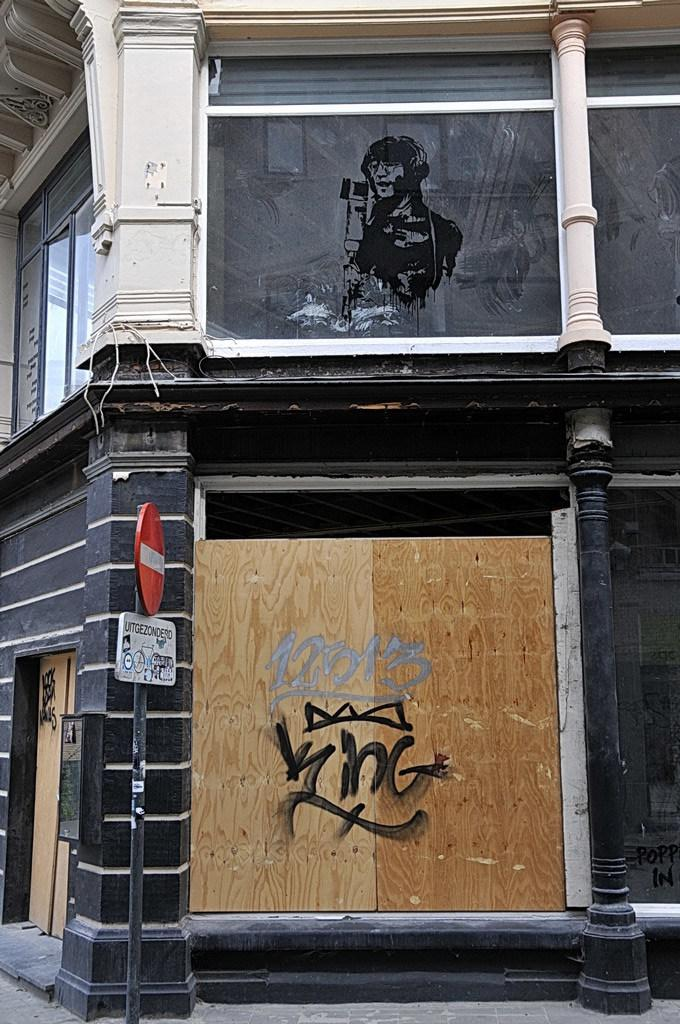What is the main subject of the image? There is a painting in the image. Are there any other paintings visible in the image? Yes, there are paintings on the wall. What else can be seen in the image besides the paintings? There is a sign board in the image. What type of shirt is the painting wearing in the image? The painting is not a person and therefore does not wear a shirt. The painting is an artwork and does not have clothing. 